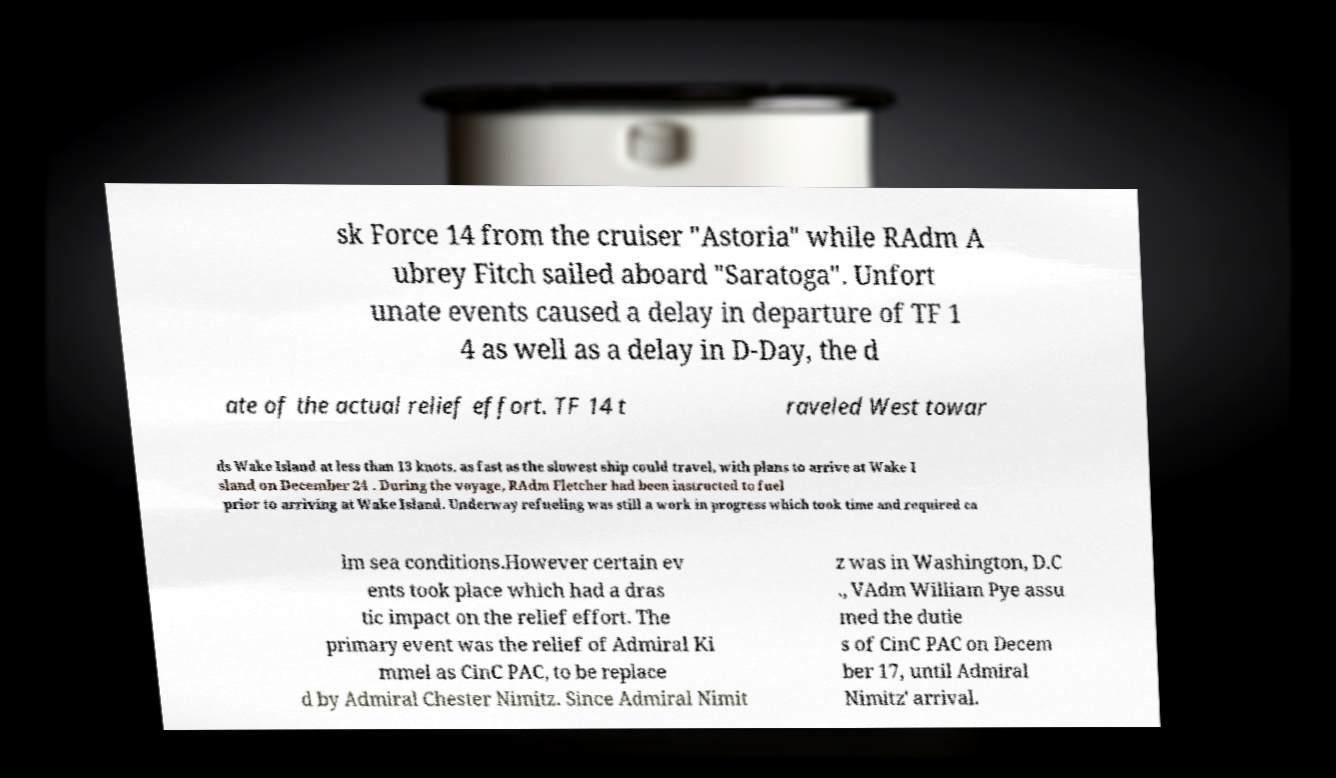I need the written content from this picture converted into text. Can you do that? sk Force 14 from the cruiser "Astoria" while RAdm A ubrey Fitch sailed aboard "Saratoga". Unfort unate events caused a delay in departure of TF 1 4 as well as a delay in D-Day, the d ate of the actual relief effort. TF 14 t raveled West towar ds Wake Island at less than 13 knots, as fast as the slowest ship could travel, with plans to arrive at Wake I sland on December 24 . During the voyage, RAdm Fletcher had been instructed to fuel prior to arriving at Wake Island. Underway refueling was still a work in progress which took time and required ca lm sea conditions.However certain ev ents took place which had a dras tic impact on the relief effort. The primary event was the relief of Admiral Ki mmel as CinC PAC, to be replace d by Admiral Chester Nimitz. Since Admiral Nimit z was in Washington, D.C ., VAdm William Pye assu med the dutie s of CinC PAC on Decem ber 17, until Admiral Nimitz' arrival. 